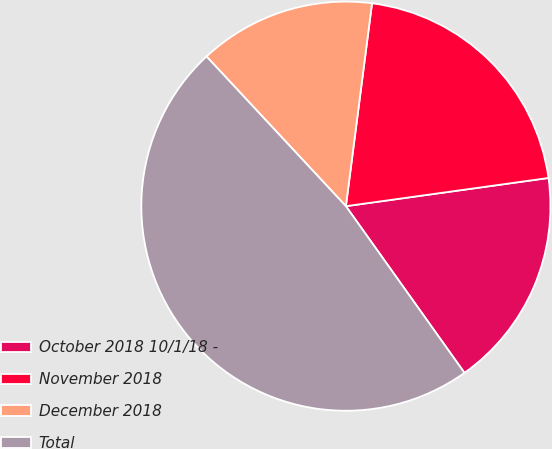<chart> <loc_0><loc_0><loc_500><loc_500><pie_chart><fcel>October 2018 10/1/18 -<fcel>November 2018<fcel>December 2018<fcel>Total<nl><fcel>17.36%<fcel>20.76%<fcel>13.97%<fcel>47.91%<nl></chart> 